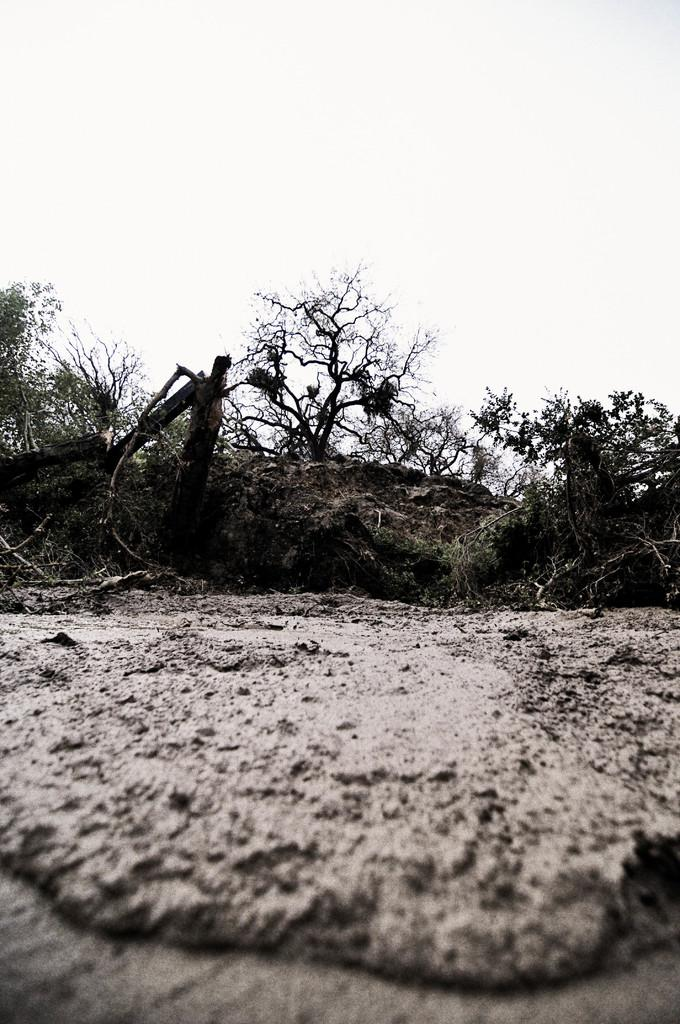What type of terrain is depicted in the image? There is mud in the image, suggesting a wet or damp environment. What natural elements can be seen in the image? There is a group of trees and wooden logs in the image. What is visible in the background of the image? The sky is visible in the image. How would you describe the weather based on the sky in the image? The sky appears to be cloudy in the image. How many brothers are supporting the wooden logs in the image? There are no people, including brothers, present in the image to support the wooden logs. 